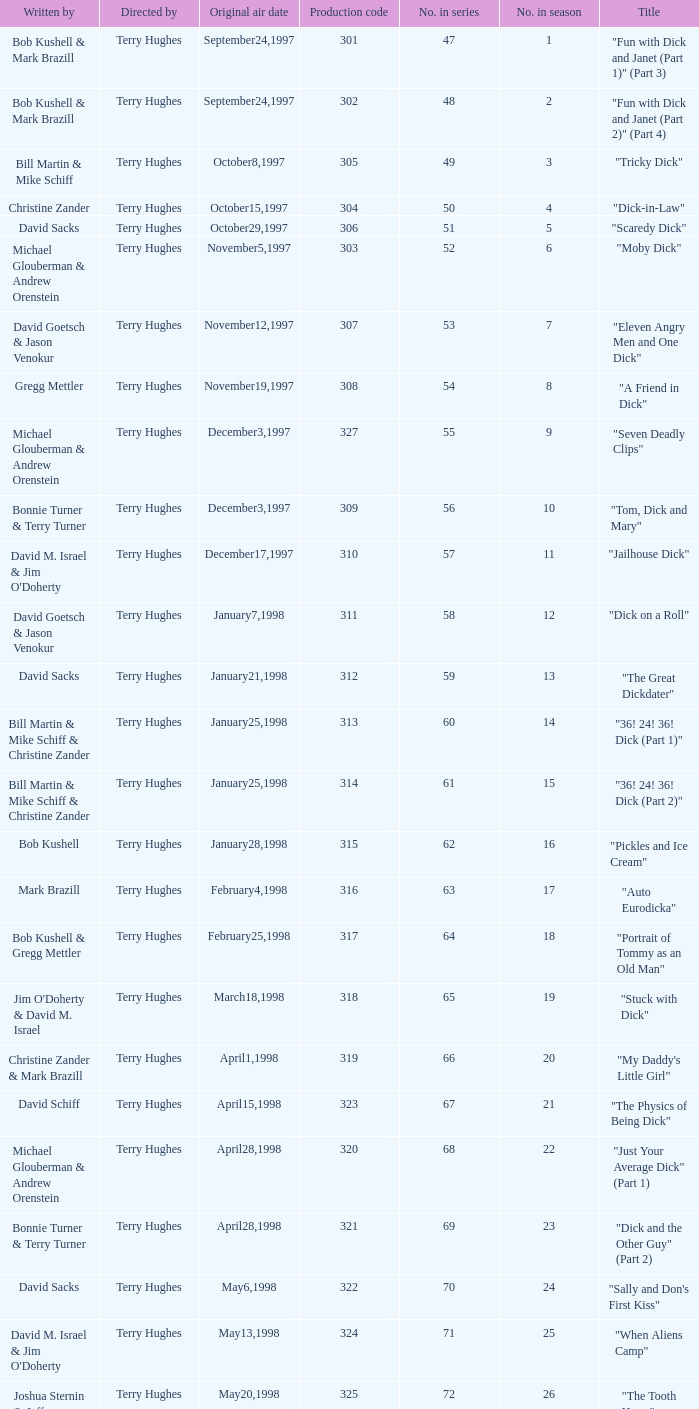What is the title of episode 10? "Tom, Dick and Mary". 